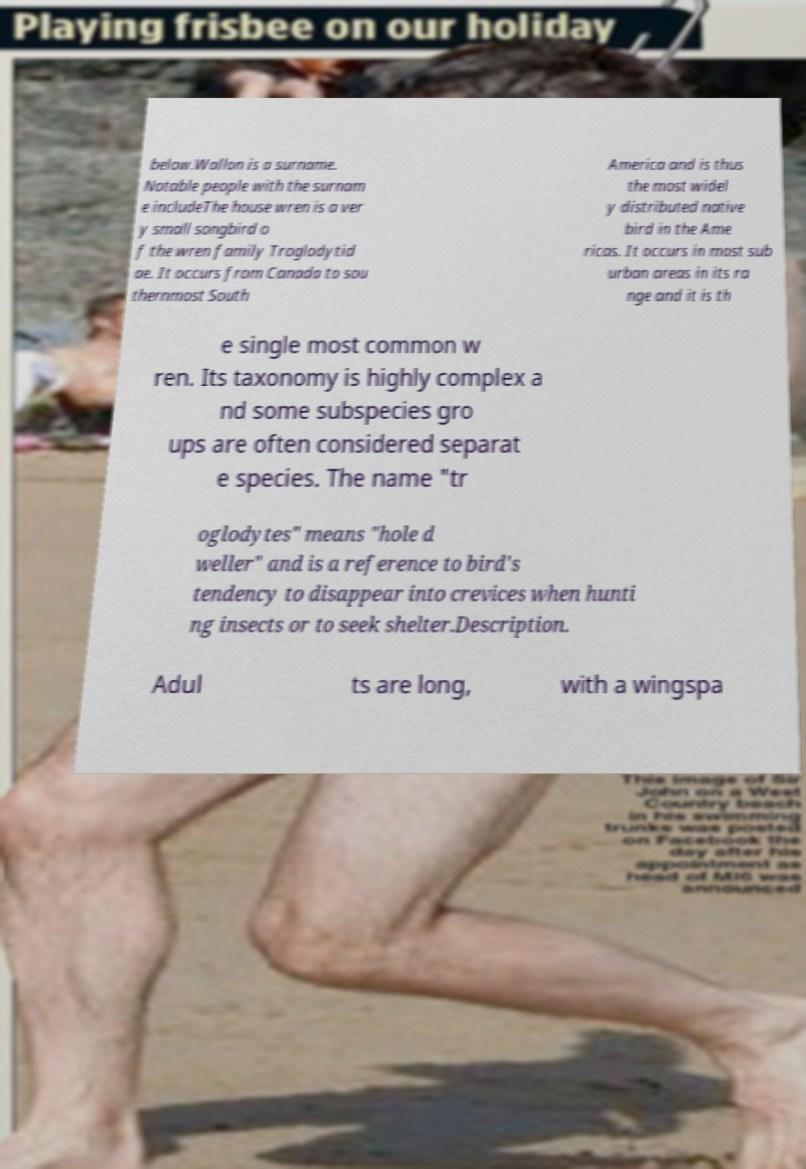What messages or text are displayed in this image? I need them in a readable, typed format. below.Wallon is a surname. Notable people with the surnam e includeThe house wren is a ver y small songbird o f the wren family Troglodytid ae. It occurs from Canada to sou thernmost South America and is thus the most widel y distributed native bird in the Ame ricas. It occurs in most sub urban areas in its ra nge and it is th e single most common w ren. Its taxonomy is highly complex a nd some subspecies gro ups are often considered separat e species. The name "tr oglodytes" means "hole d weller" and is a reference to bird's tendency to disappear into crevices when hunti ng insects or to seek shelter.Description. Adul ts are long, with a wingspa 